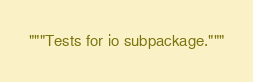Convert code to text. <code><loc_0><loc_0><loc_500><loc_500><_Python_>"""Tests for io subpackage."""
</code> 